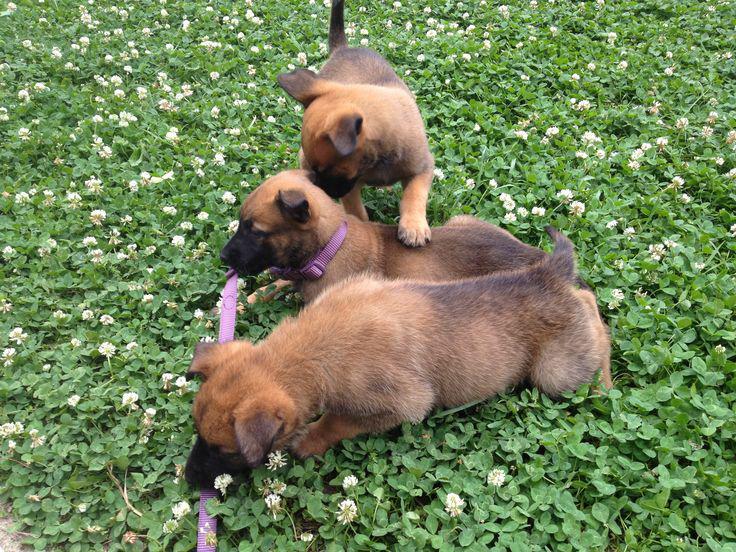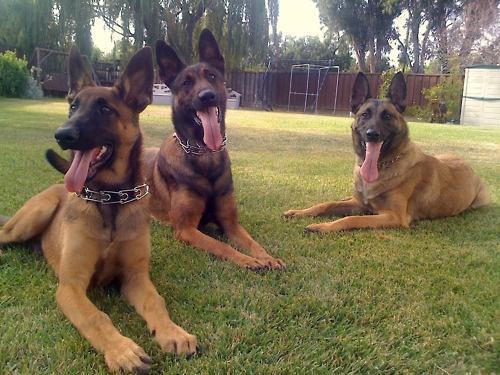The first image is the image on the left, the second image is the image on the right. Given the left and right images, does the statement "Three german shepherd dogs sit upright in a row on grass in one image." hold true? Answer yes or no. No. The first image is the image on the left, the second image is the image on the right. Considering the images on both sides, is "The right image contains exactly three dogs." valid? Answer yes or no. Yes. 